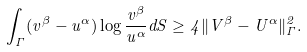<formula> <loc_0><loc_0><loc_500><loc_500>\int _ { \Gamma } ( v ^ { \beta } - u ^ { \alpha } ) \log \frac { v ^ { \beta } } { u ^ { \alpha } } d S \geq 4 \| V ^ { \beta } - U ^ { \alpha } \| _ { \Gamma } ^ { 2 } .</formula> 